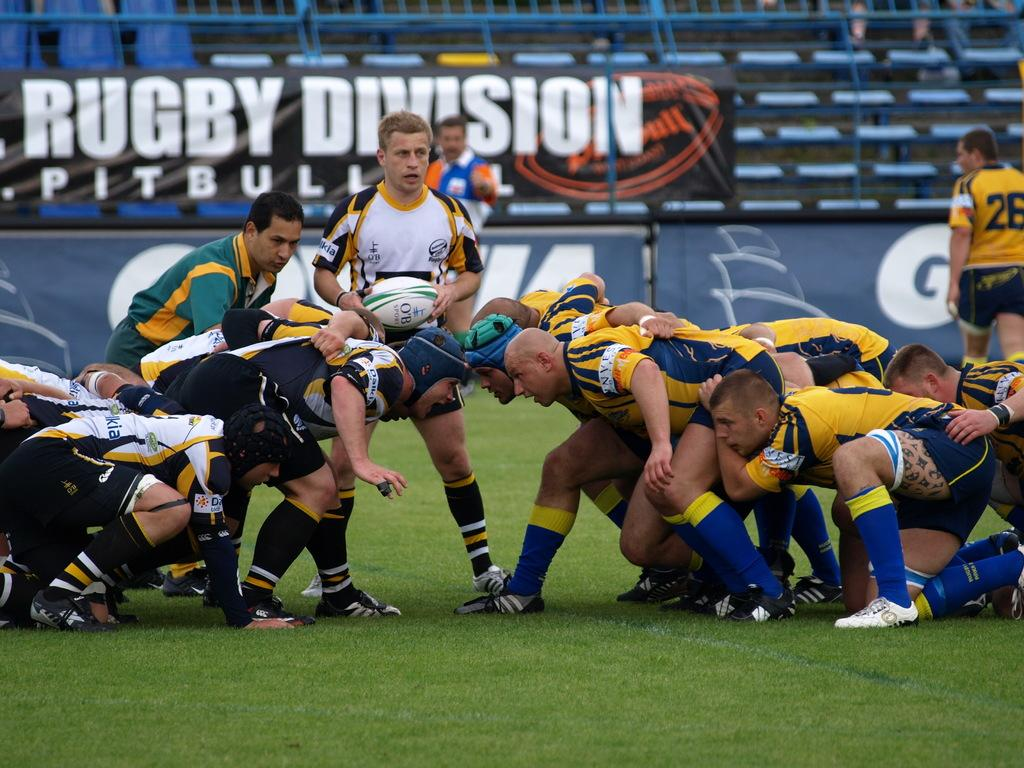Provide a one-sentence caption for the provided image. A rugby game takes place in front of a banner that says Rugby Division Pitbull. 